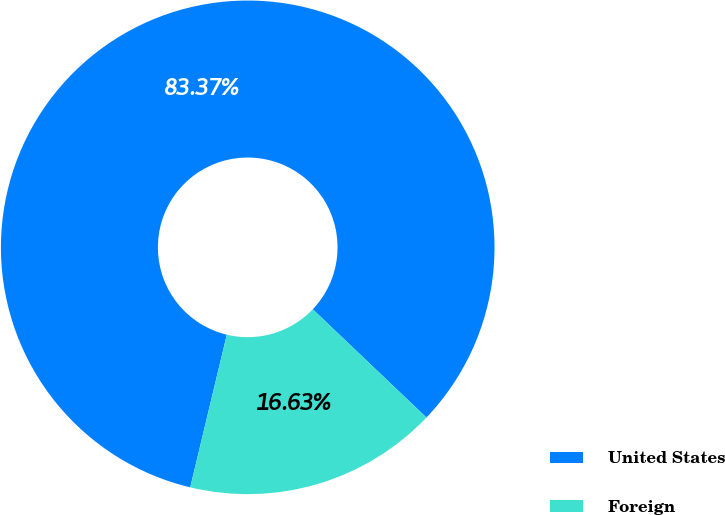Convert chart to OTSL. <chart><loc_0><loc_0><loc_500><loc_500><pie_chart><fcel>United States<fcel>Foreign<nl><fcel>83.37%<fcel>16.63%<nl></chart> 